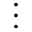Convert formula to latex. <formula><loc_0><loc_0><loc_500><loc_500>\vdots</formula> 